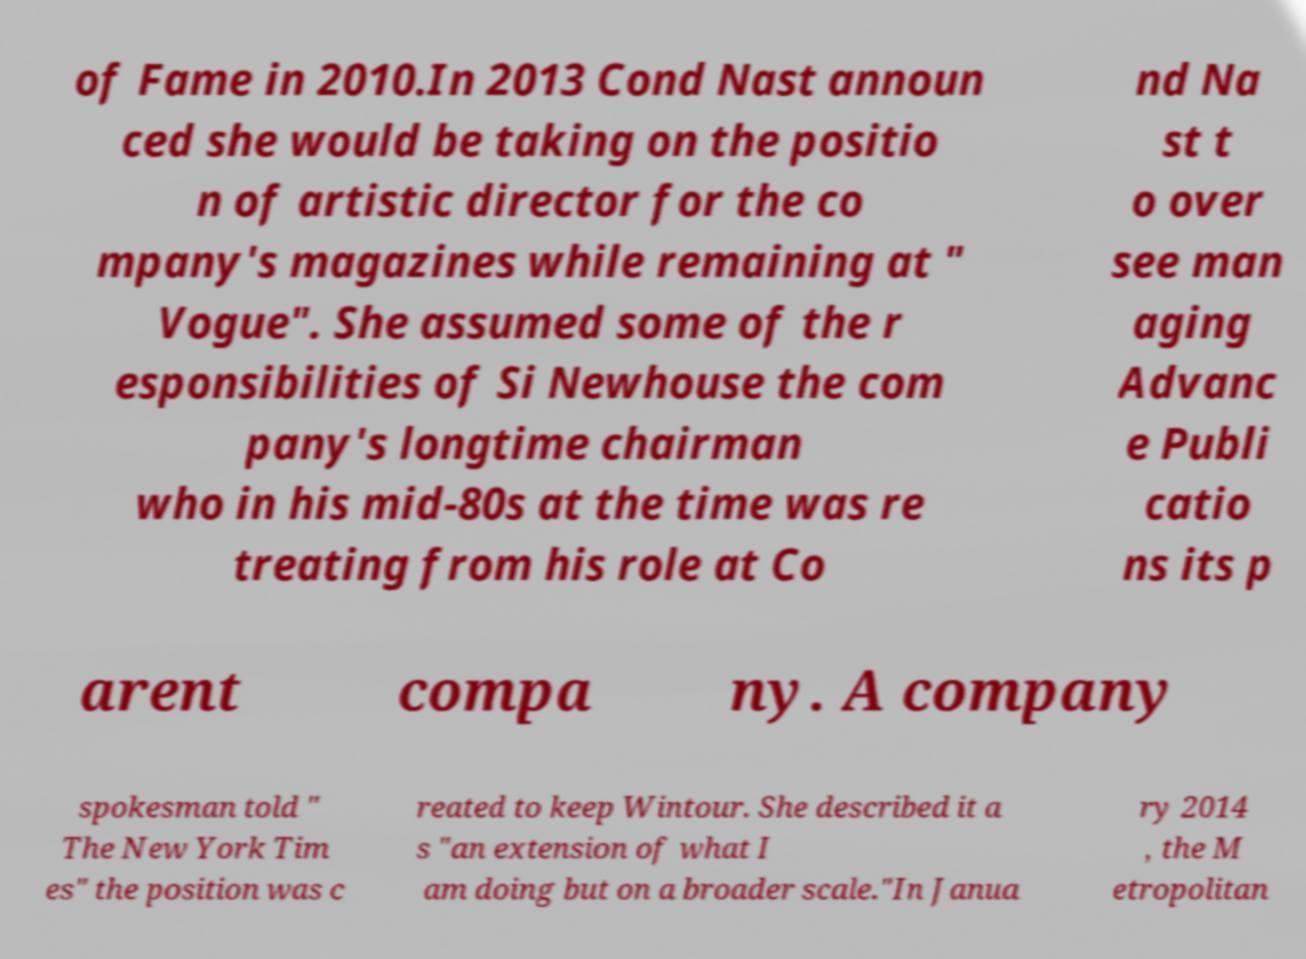Please identify and transcribe the text found in this image. of Fame in 2010.In 2013 Cond Nast announ ced she would be taking on the positio n of artistic director for the co mpany's magazines while remaining at " Vogue". She assumed some of the r esponsibilities of Si Newhouse the com pany's longtime chairman who in his mid-80s at the time was re treating from his role at Co nd Na st t o over see man aging Advanc e Publi catio ns its p arent compa ny. A company spokesman told " The New York Tim es" the position was c reated to keep Wintour. She described it a s "an extension of what I am doing but on a broader scale."In Janua ry 2014 , the M etropolitan 